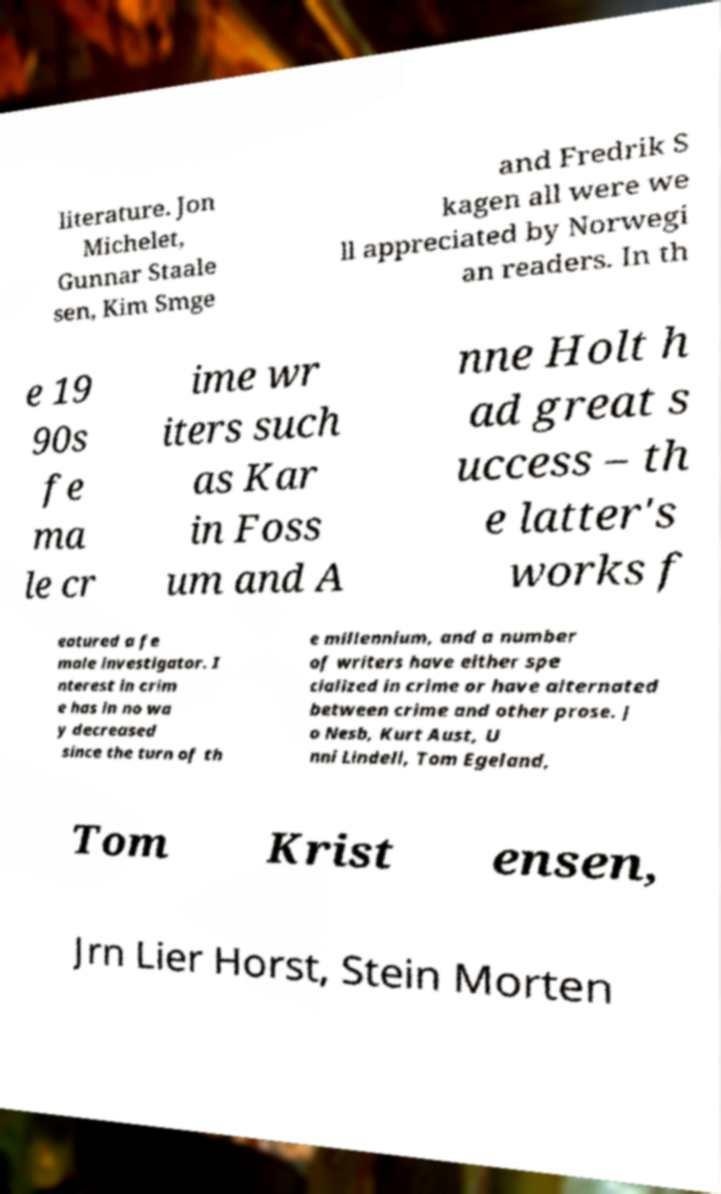I need the written content from this picture converted into text. Can you do that? literature. Jon Michelet, Gunnar Staale sen, Kim Smge and Fredrik S kagen all were we ll appreciated by Norwegi an readers. In th e 19 90s fe ma le cr ime wr iters such as Kar in Foss um and A nne Holt h ad great s uccess – th e latter's works f eatured a fe male investigator. I nterest in crim e has in no wa y decreased since the turn of th e millennium, and a number of writers have either spe cialized in crime or have alternated between crime and other prose. J o Nesb, Kurt Aust, U nni Lindell, Tom Egeland, Tom Krist ensen, Jrn Lier Horst, Stein Morten 